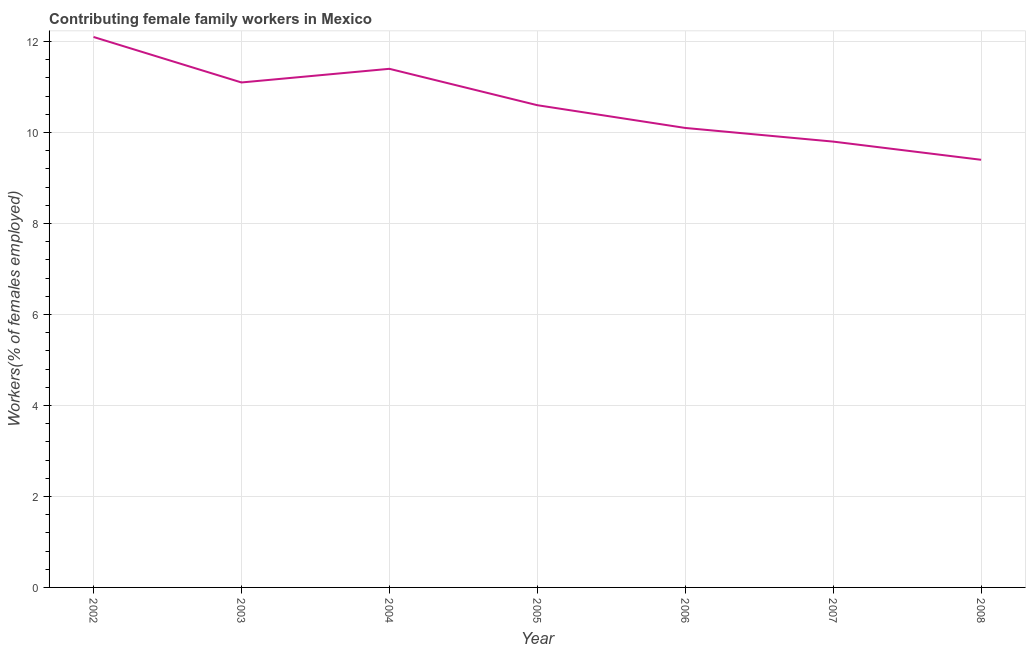What is the contributing female family workers in 2005?
Your answer should be very brief. 10.6. Across all years, what is the maximum contributing female family workers?
Provide a short and direct response. 12.1. Across all years, what is the minimum contributing female family workers?
Keep it short and to the point. 9.4. In which year was the contributing female family workers maximum?
Your answer should be very brief. 2002. In which year was the contributing female family workers minimum?
Your response must be concise. 2008. What is the sum of the contributing female family workers?
Your answer should be compact. 74.5. What is the difference between the contributing female family workers in 2005 and 2008?
Your answer should be very brief. 1.2. What is the average contributing female family workers per year?
Give a very brief answer. 10.64. What is the median contributing female family workers?
Offer a very short reply. 10.6. Do a majority of the years between 2004 and 2002 (inclusive) have contributing female family workers greater than 4.4 %?
Provide a short and direct response. No. What is the ratio of the contributing female family workers in 2005 to that in 2008?
Offer a terse response. 1.13. What is the difference between the highest and the second highest contributing female family workers?
Your answer should be very brief. 0.7. Is the sum of the contributing female family workers in 2005 and 2007 greater than the maximum contributing female family workers across all years?
Make the answer very short. Yes. What is the difference between the highest and the lowest contributing female family workers?
Give a very brief answer. 2.7. Does the contributing female family workers monotonically increase over the years?
Provide a short and direct response. No. How many lines are there?
Give a very brief answer. 1. How many years are there in the graph?
Offer a terse response. 7. Does the graph contain any zero values?
Make the answer very short. No. Does the graph contain grids?
Your response must be concise. Yes. What is the title of the graph?
Ensure brevity in your answer.  Contributing female family workers in Mexico. What is the label or title of the Y-axis?
Offer a very short reply. Workers(% of females employed). What is the Workers(% of females employed) of 2002?
Your answer should be compact. 12.1. What is the Workers(% of females employed) of 2003?
Provide a succinct answer. 11.1. What is the Workers(% of females employed) in 2004?
Your response must be concise. 11.4. What is the Workers(% of females employed) of 2005?
Give a very brief answer. 10.6. What is the Workers(% of females employed) in 2006?
Offer a very short reply. 10.1. What is the Workers(% of females employed) of 2007?
Make the answer very short. 9.8. What is the Workers(% of females employed) in 2008?
Make the answer very short. 9.4. What is the difference between the Workers(% of females employed) in 2002 and 2003?
Your answer should be compact. 1. What is the difference between the Workers(% of females employed) in 2002 and 2004?
Keep it short and to the point. 0.7. What is the difference between the Workers(% of females employed) in 2002 and 2005?
Make the answer very short. 1.5. What is the difference between the Workers(% of females employed) in 2002 and 2006?
Your answer should be compact. 2. What is the difference between the Workers(% of females employed) in 2003 and 2004?
Keep it short and to the point. -0.3. What is the difference between the Workers(% of females employed) in 2003 and 2007?
Provide a short and direct response. 1.3. What is the difference between the Workers(% of females employed) in 2005 and 2006?
Make the answer very short. 0.5. What is the difference between the Workers(% of females employed) in 2005 and 2007?
Provide a short and direct response. 0.8. What is the difference between the Workers(% of females employed) in 2005 and 2008?
Your response must be concise. 1.2. What is the difference between the Workers(% of females employed) in 2007 and 2008?
Provide a short and direct response. 0.4. What is the ratio of the Workers(% of females employed) in 2002 to that in 2003?
Your response must be concise. 1.09. What is the ratio of the Workers(% of females employed) in 2002 to that in 2004?
Offer a terse response. 1.06. What is the ratio of the Workers(% of females employed) in 2002 to that in 2005?
Make the answer very short. 1.14. What is the ratio of the Workers(% of females employed) in 2002 to that in 2006?
Make the answer very short. 1.2. What is the ratio of the Workers(% of females employed) in 2002 to that in 2007?
Provide a succinct answer. 1.24. What is the ratio of the Workers(% of females employed) in 2002 to that in 2008?
Provide a short and direct response. 1.29. What is the ratio of the Workers(% of females employed) in 2003 to that in 2004?
Offer a very short reply. 0.97. What is the ratio of the Workers(% of females employed) in 2003 to that in 2005?
Ensure brevity in your answer.  1.05. What is the ratio of the Workers(% of females employed) in 2003 to that in 2006?
Ensure brevity in your answer.  1.1. What is the ratio of the Workers(% of females employed) in 2003 to that in 2007?
Provide a short and direct response. 1.13. What is the ratio of the Workers(% of females employed) in 2003 to that in 2008?
Ensure brevity in your answer.  1.18. What is the ratio of the Workers(% of females employed) in 2004 to that in 2005?
Your response must be concise. 1.07. What is the ratio of the Workers(% of females employed) in 2004 to that in 2006?
Provide a succinct answer. 1.13. What is the ratio of the Workers(% of females employed) in 2004 to that in 2007?
Your response must be concise. 1.16. What is the ratio of the Workers(% of females employed) in 2004 to that in 2008?
Make the answer very short. 1.21. What is the ratio of the Workers(% of females employed) in 2005 to that in 2007?
Make the answer very short. 1.08. What is the ratio of the Workers(% of females employed) in 2005 to that in 2008?
Your response must be concise. 1.13. What is the ratio of the Workers(% of females employed) in 2006 to that in 2007?
Give a very brief answer. 1.03. What is the ratio of the Workers(% of females employed) in 2006 to that in 2008?
Offer a terse response. 1.07. What is the ratio of the Workers(% of females employed) in 2007 to that in 2008?
Your answer should be compact. 1.04. 